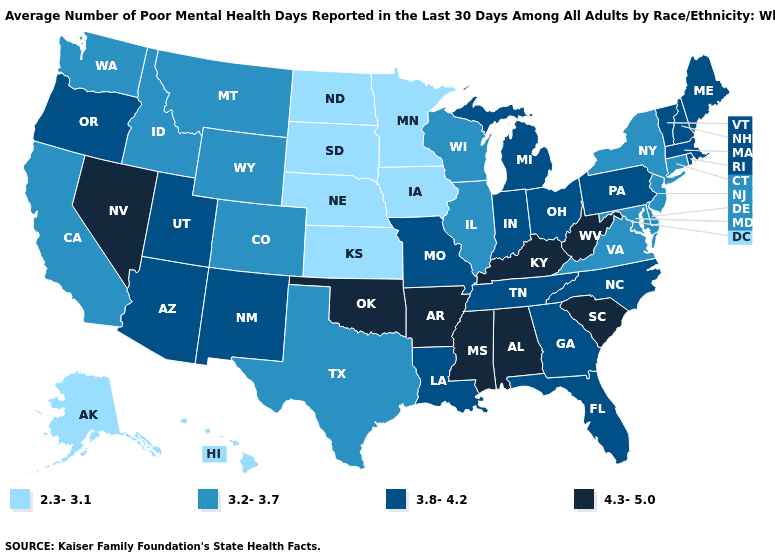Among the states that border New Mexico , does Arizona have the highest value?
Be succinct. No. Name the states that have a value in the range 3.2-3.7?
Quick response, please. California, Colorado, Connecticut, Delaware, Idaho, Illinois, Maryland, Montana, New Jersey, New York, Texas, Virginia, Washington, Wisconsin, Wyoming. Does the map have missing data?
Answer briefly. No. Name the states that have a value in the range 2.3-3.1?
Answer briefly. Alaska, Hawaii, Iowa, Kansas, Minnesota, Nebraska, North Dakota, South Dakota. Is the legend a continuous bar?
Give a very brief answer. No. Is the legend a continuous bar?
Give a very brief answer. No. Name the states that have a value in the range 3.2-3.7?
Answer briefly. California, Colorado, Connecticut, Delaware, Idaho, Illinois, Maryland, Montana, New Jersey, New York, Texas, Virginia, Washington, Wisconsin, Wyoming. Name the states that have a value in the range 3.2-3.7?
Answer briefly. California, Colorado, Connecticut, Delaware, Idaho, Illinois, Maryland, Montana, New Jersey, New York, Texas, Virginia, Washington, Wisconsin, Wyoming. What is the value of New Mexico?
Give a very brief answer. 3.8-4.2. Name the states that have a value in the range 3.8-4.2?
Short answer required. Arizona, Florida, Georgia, Indiana, Louisiana, Maine, Massachusetts, Michigan, Missouri, New Hampshire, New Mexico, North Carolina, Ohio, Oregon, Pennsylvania, Rhode Island, Tennessee, Utah, Vermont. Name the states that have a value in the range 3.8-4.2?
Answer briefly. Arizona, Florida, Georgia, Indiana, Louisiana, Maine, Massachusetts, Michigan, Missouri, New Hampshire, New Mexico, North Carolina, Ohio, Oregon, Pennsylvania, Rhode Island, Tennessee, Utah, Vermont. Is the legend a continuous bar?
Give a very brief answer. No. What is the highest value in states that border Georgia?
Write a very short answer. 4.3-5.0. What is the value of Tennessee?
Write a very short answer. 3.8-4.2. Which states have the lowest value in the MidWest?
Concise answer only. Iowa, Kansas, Minnesota, Nebraska, North Dakota, South Dakota. 